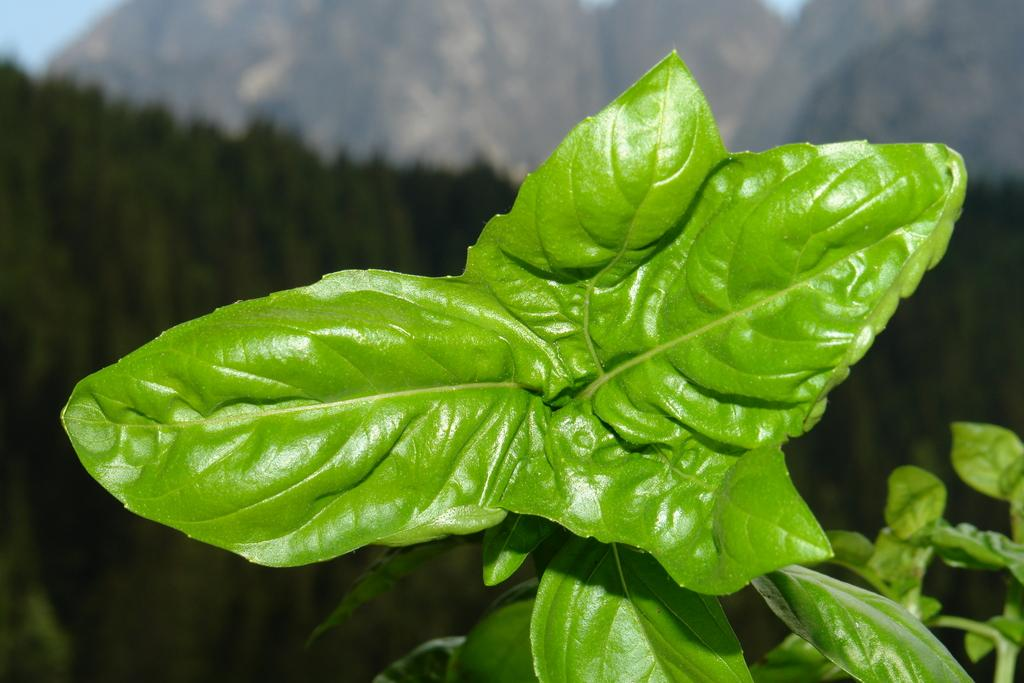What is located in the center of the image? There are leaves in the center of the image. What can be seen in the background of the image? There are trees and hills in the background of the image. What is visible in the sky in the image? The sky is visible in the background of the image. What type of organization is responsible for the smoke in the image? There is no smoke present in the image, so it is not possible to determine which organization might be responsible. 